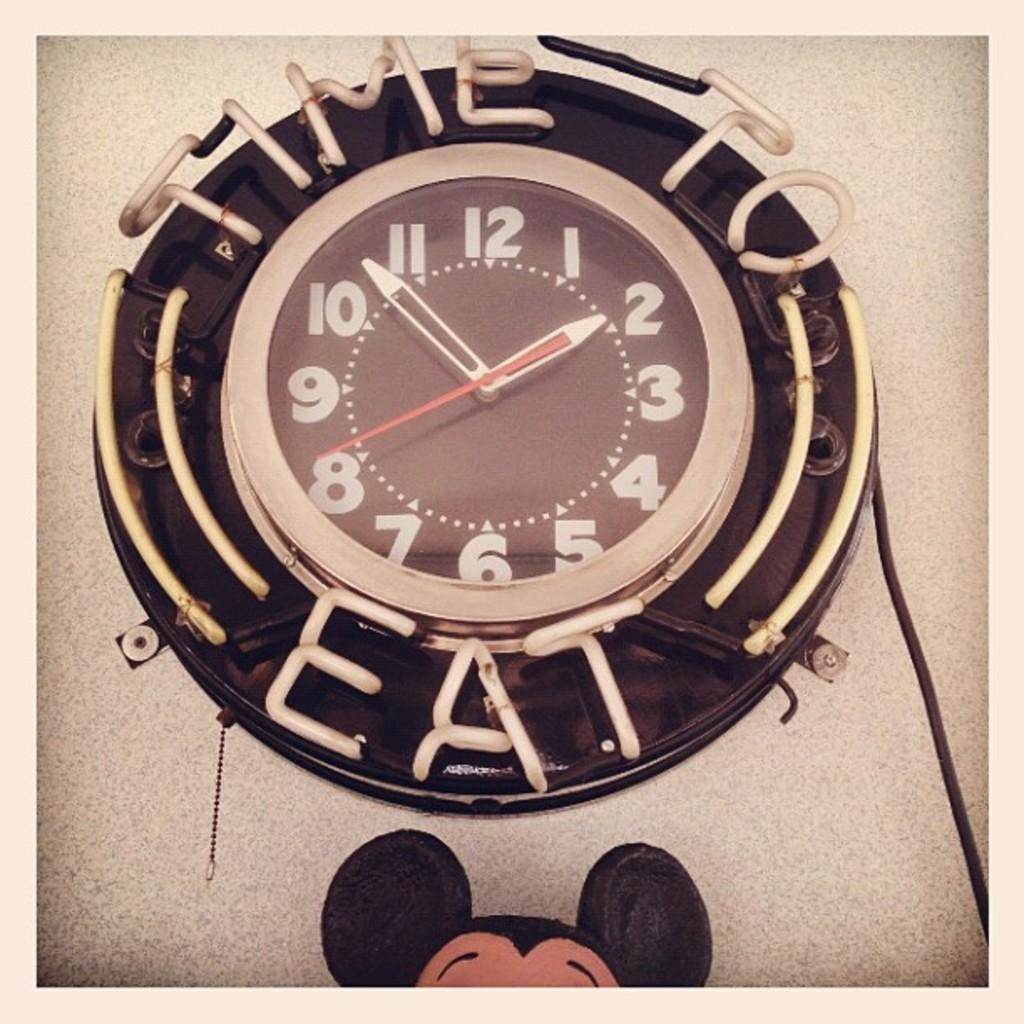<image>
Summarize the visual content of the image. A clock displaying 2:54 with Time to Eat written on it. 